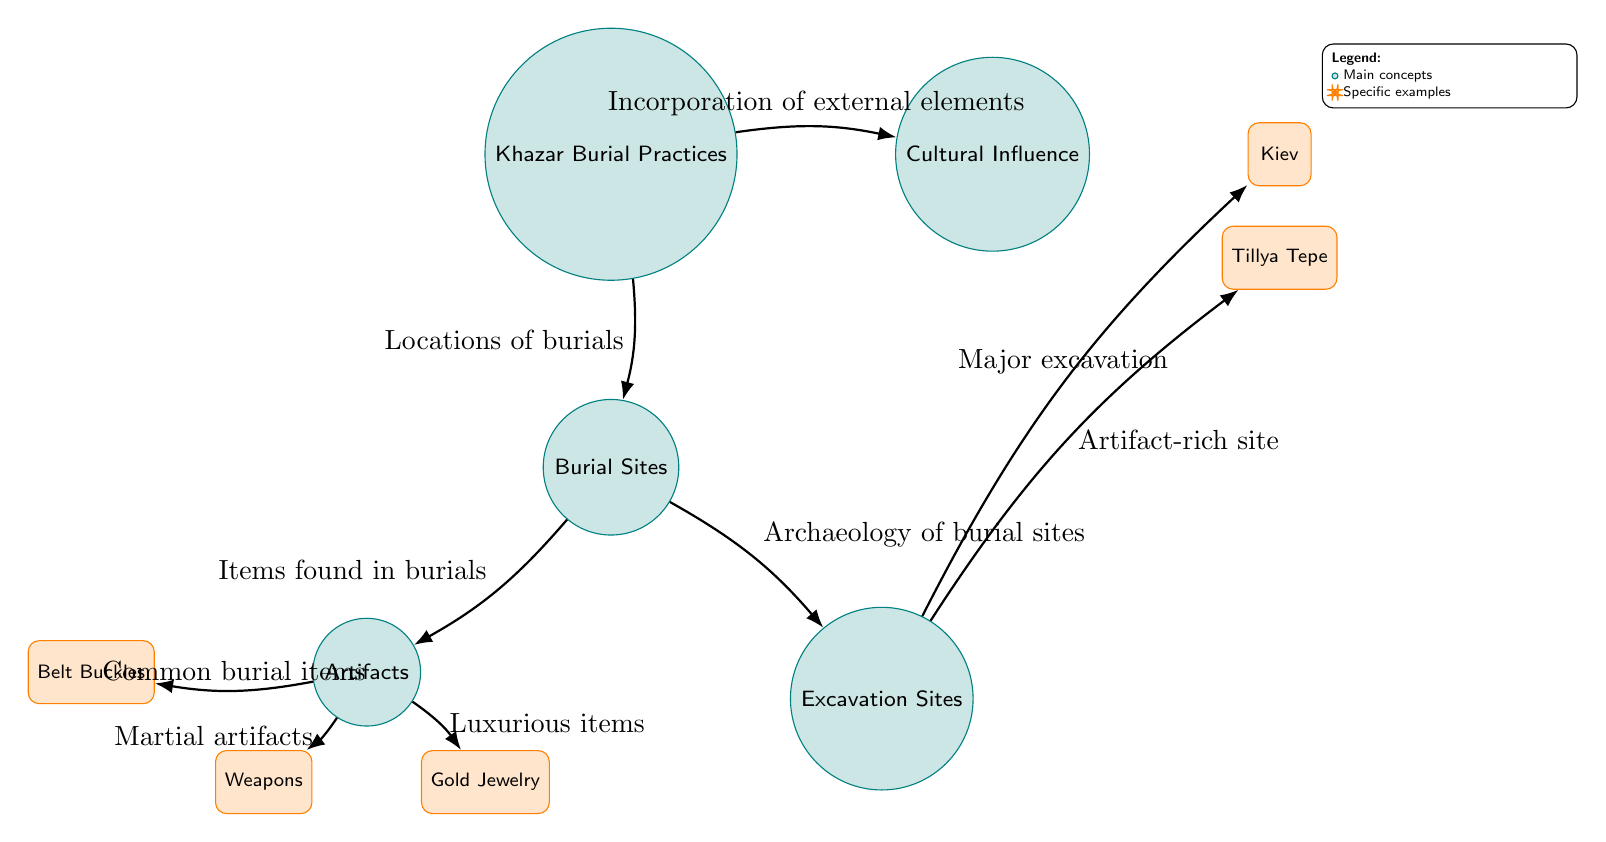What node represents burial locations? The node labeled 'Burial Sites' directly outlines the locations of burials in the diagram. This node is placed directly beneath the 'Khazar Burial Practices' node, indicating its relationship.
Answer: Burial Sites How many main nodes are in the diagram? The main nodes are 'Khazar Burial Practices', 'Cultural Influence', 'Burial Sites', 'Excavation Sites', and 'Artifacts'. Counting these, there are a total of five main nodes present in the diagram.
Answer: 5 What is the relationship between 'Excavation Sites' and 'Kiev'? The diagram shows an edge labeled 'Major excavation' between 'Excavation Sites' and 'Kiev'. This indicates that the excavation at this site was significant and noteworthy.
Answer: Major excavation What type of items are associated with 'Artifacts'? The diagram indicates three types of items under 'Artifacts': 'Belt Buckles', 'Weapons', and 'Gold Jewelry'. These items categorize the types of artifacts found in burials.
Answer: Belt Buckles, Weapons, Gold Jewelry How does 'Cultural Influence' connect to 'Khazar Burial Practices'? There is an edge labeled 'Incorporation of external elements' that connects 'Cultural Influence' to 'Khazar Burial Practices', illustrating that external cultural aspects influenced these practices.
Answer: Incorporation of external elements Which burial practice is linked to 'Tillya Tepe'? The edge from 'Excavation Sites' to 'Tillya Tepe' shows that this site is considered an artifact-rich site, implying significance in burial practices associated with it.
Answer: Artifact-rich site What does 'Weapons' signify about the burial items? The edge labeled 'Martial artifacts' connects 'Weapons' to 'Artifacts', indicating that weapons found in the burial site are characterized as martial objects, suggesting a martial aspect of the culture.
Answer: Martial artifacts What does the legend in the diagram explain? The legend distinguishes between main concepts and specific examples, clarifying how to interpret the nodes in the diagram. It specifies that main concepts are represented by circles and specific examples by rounded rectangles.
Answer: Main concepts and specific examples 